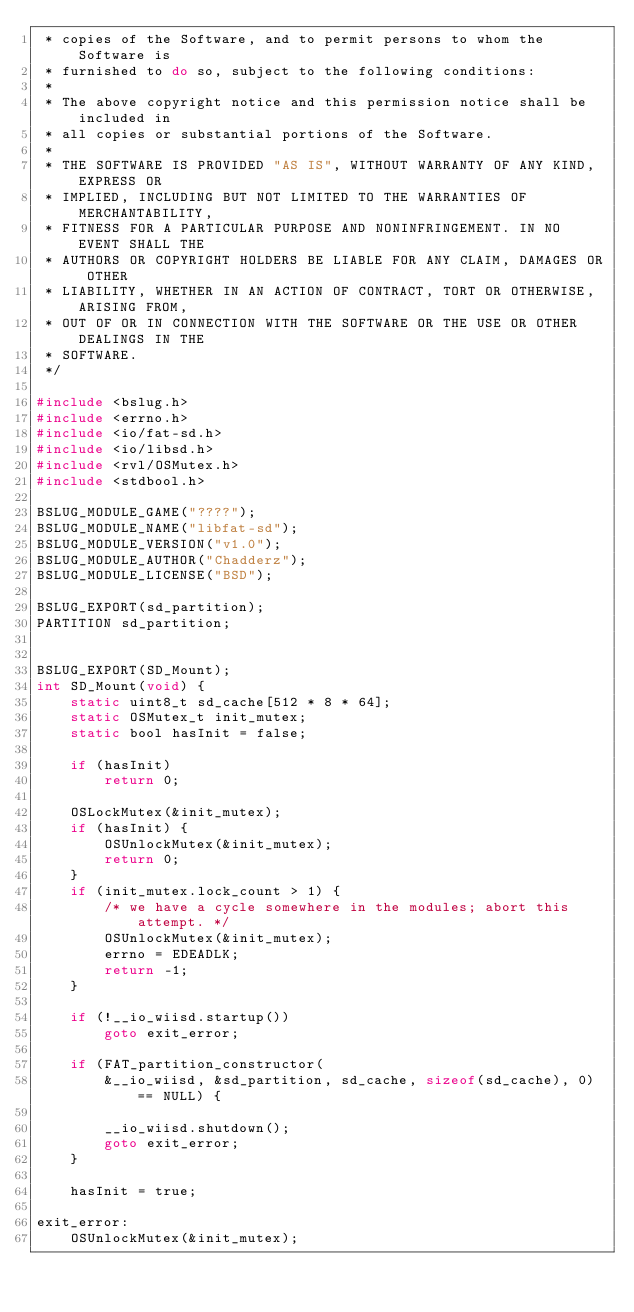<code> <loc_0><loc_0><loc_500><loc_500><_C_> * copies of the Software, and to permit persons to whom the Software is
 * furnished to do so, subject to the following conditions:
 *
 * The above copyright notice and this permission notice shall be included in
 * all copies or substantial portions of the Software.
 *
 * THE SOFTWARE IS PROVIDED "AS IS", WITHOUT WARRANTY OF ANY KIND, EXPRESS OR
 * IMPLIED, INCLUDING BUT NOT LIMITED TO THE WARRANTIES OF MERCHANTABILITY,
 * FITNESS FOR A PARTICULAR PURPOSE AND NONINFRINGEMENT. IN NO EVENT SHALL THE
 * AUTHORS OR COPYRIGHT HOLDERS BE LIABLE FOR ANY CLAIM, DAMAGES OR OTHER
 * LIABILITY, WHETHER IN AN ACTION OF CONTRACT, TORT OR OTHERWISE, ARISING FROM,
 * OUT OF OR IN CONNECTION WITH THE SOFTWARE OR THE USE OR OTHER DEALINGS IN THE
 * SOFTWARE.
 */

#include <bslug.h>
#include <errno.h>
#include <io/fat-sd.h>
#include <io/libsd.h>
#include <rvl/OSMutex.h>
#include <stdbool.h>

BSLUG_MODULE_GAME("????");
BSLUG_MODULE_NAME("libfat-sd");
BSLUG_MODULE_VERSION("v1.0");
BSLUG_MODULE_AUTHOR("Chadderz");
BSLUG_MODULE_LICENSE("BSD");

BSLUG_EXPORT(sd_partition);
PARTITION sd_partition;


BSLUG_EXPORT(SD_Mount);
int SD_Mount(void) {
    static uint8_t sd_cache[512 * 8 * 64];
    static OSMutex_t init_mutex;
    static bool hasInit = false;
    
    if (hasInit)
        return 0;
        
    OSLockMutex(&init_mutex);
    if (hasInit) {
        OSUnlockMutex(&init_mutex);
        return 0;
    }
    if (init_mutex.lock_count > 1) {
        /* we have a cycle somewhere in the modules; abort this attempt. */
        OSUnlockMutex(&init_mutex);
        errno = EDEADLK;
        return -1;
    }
    
    if (!__io_wiisd.startup())
        goto exit_error;
    
    if (FAT_partition_constructor(
        &__io_wiisd, &sd_partition, sd_cache, sizeof(sd_cache), 0) == NULL) {
     
        __io_wiisd.shutdown();
        goto exit_error;
    }
    
    hasInit = true;

exit_error:
    OSUnlockMutex(&init_mutex);
    </code> 